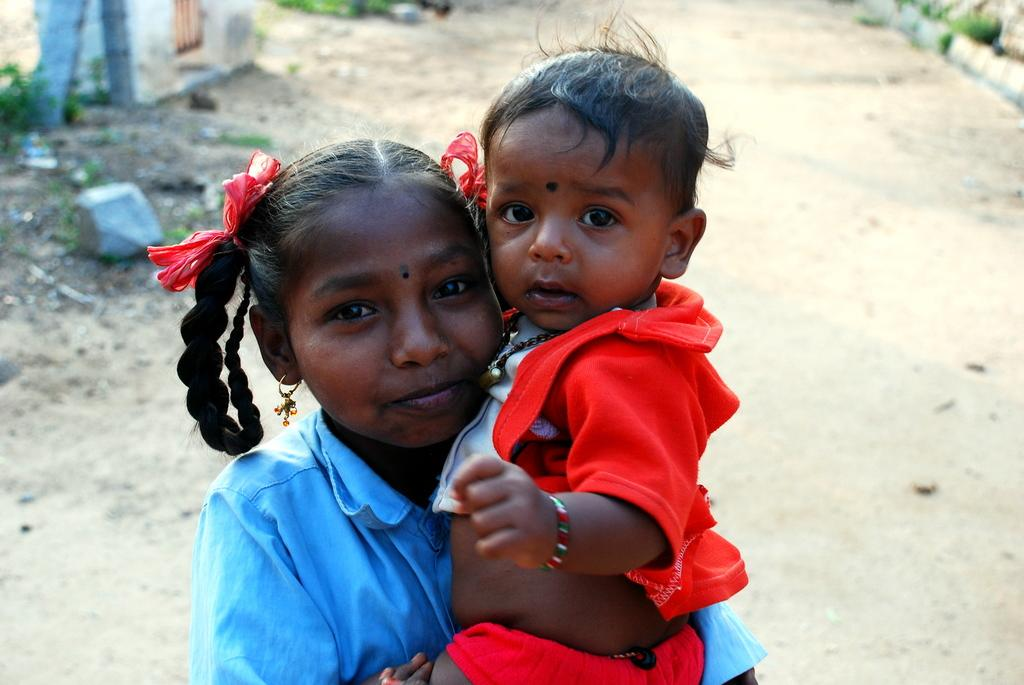What is the child in the image doing? The child is standing on the ground and holding another kid. What can be seen in the background of the image? There is a wall, a pillar, stones, and grass in the background. How many children are visible in the image? There are two children visible in the image. What type of hydrant is present in the image? There is no hydrant present in the image. What is the texture of the chin of the child holding the other kid? The image does not provide enough detail to determine the texture of the child's chin. 